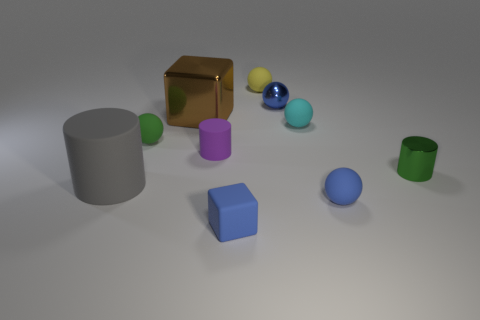Subtract all cyan cylinders. How many blue spheres are left? 2 Subtract all tiny cylinders. How many cylinders are left? 1 Subtract 1 spheres. How many spheres are left? 4 Subtract all blue spheres. How many spheres are left? 3 Subtract all cyan cylinders. Subtract all brown spheres. How many cylinders are left? 3 Subtract all cylinders. How many objects are left? 7 Subtract 1 gray cylinders. How many objects are left? 9 Subtract all small cyan objects. Subtract all metallic blocks. How many objects are left? 8 Add 1 gray things. How many gray things are left? 2 Add 6 large cylinders. How many large cylinders exist? 7 